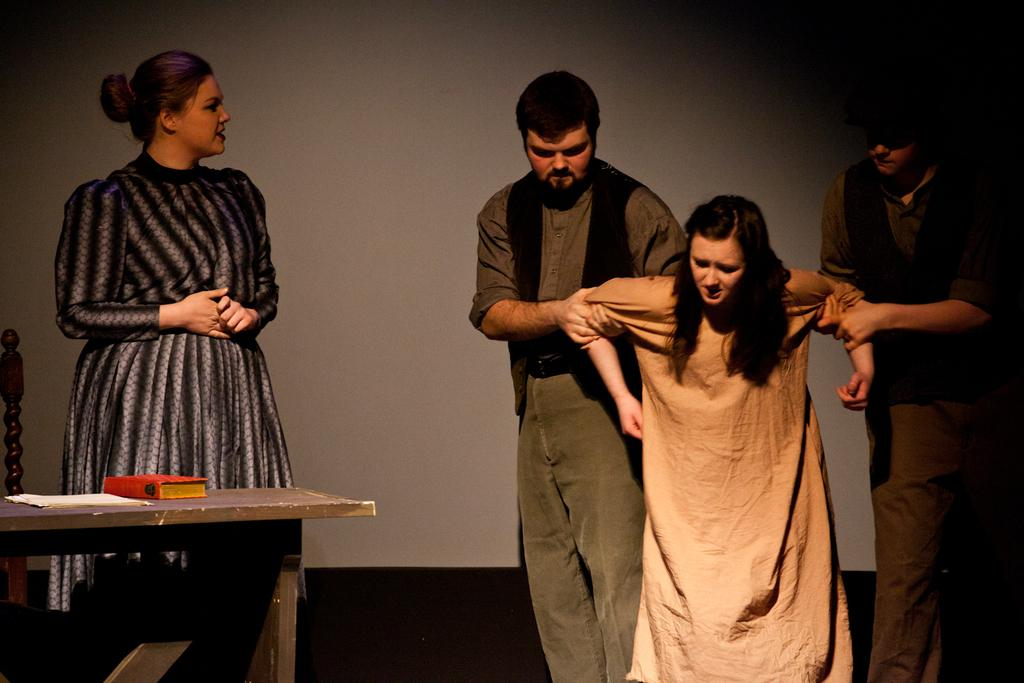How many people are in the image? There are four people in the image. Can you describe the gender of the people in the image? Two of the people are men, and two are women. What might the people be doing in the image? The people may be acting in a play. Where is the table located in the image? The table is on the left side of the image. What is on the table in the image? The table has a book on it. What type of wren can be seen flying through the door in the image? There is no wren or door present in the image. What type of juice is being served at the table in the image? There is no juice present in the image; the table has a book on it. 